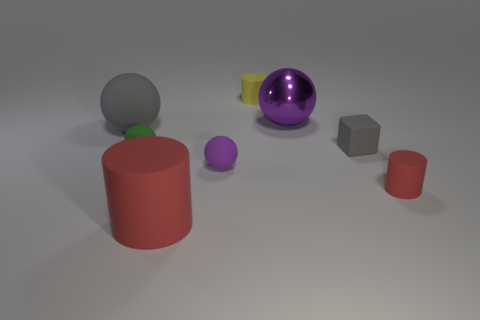What number of spheres are either small green things or large gray objects?
Provide a succinct answer. 2. Is there anything else that has the same size as the gray matte ball?
Your answer should be very brief. Yes. There is a matte cylinder that is behind the red matte thing that is on the right side of the tiny gray thing; how many cubes are right of it?
Offer a very short reply. 1. Do the small purple object and the small green thing have the same shape?
Your response must be concise. Yes. Is the material of the big object that is right of the big red matte thing the same as the purple sphere in front of the big shiny sphere?
Your answer should be compact. No. How many things are tiny rubber balls behind the tiny purple rubber sphere or balls in front of the big gray matte ball?
Offer a terse response. 2. Is there any other thing that is the same shape as the large red thing?
Keep it short and to the point. Yes. How many big objects are there?
Keep it short and to the point. 3. Is there a blue matte cube that has the same size as the metal object?
Make the answer very short. No. Is the small purple thing made of the same material as the red cylinder in front of the tiny red thing?
Ensure brevity in your answer.  Yes. 